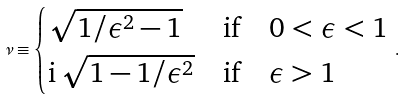<formula> <loc_0><loc_0><loc_500><loc_500>\nu \equiv \begin{cases} \sqrt { 1 / \epsilon ^ { 2 } - 1 } & \text {if} \quad 0 < \epsilon < 1 \\ \mathrm i \, \sqrt { 1 - 1 / \epsilon ^ { 2 } } & \text {if} \quad \epsilon > 1 \end{cases} \, .</formula> 